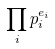<formula> <loc_0><loc_0><loc_500><loc_500>\prod _ { i } p _ { i } ^ { e _ { i } }</formula> 